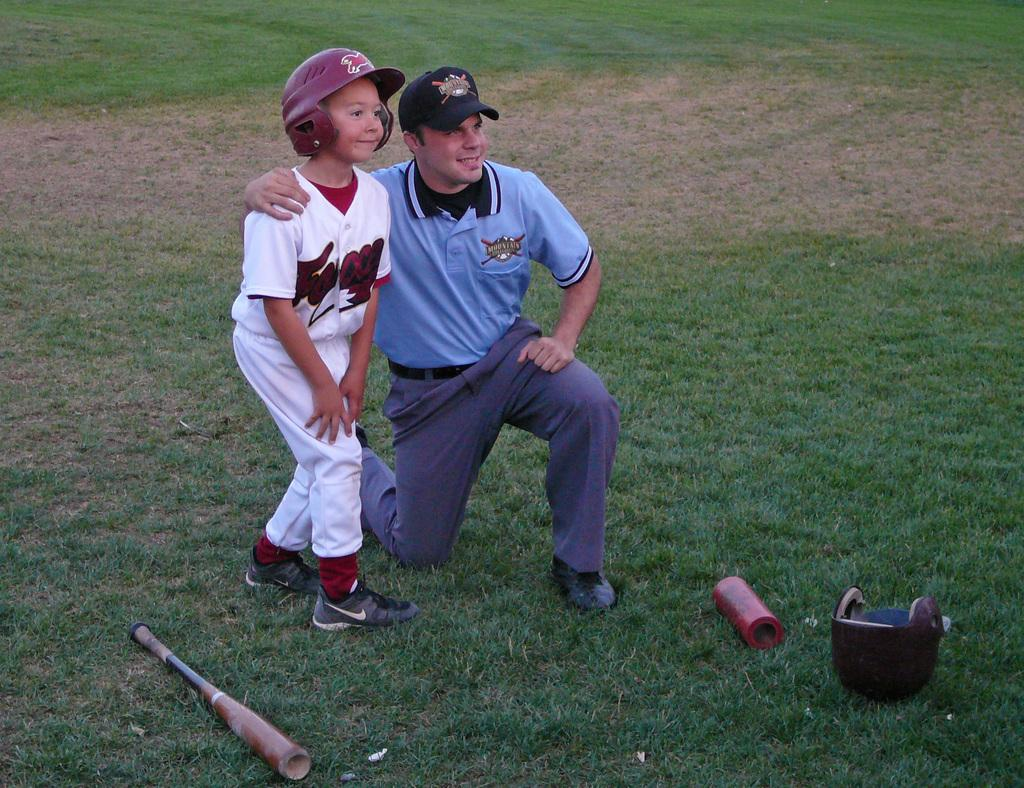How many people are in the image? There are two people in the image. What is the facial expression of the people in the image? The people are smiling. What sport-related item is present in the image? There is a bat and a helmet in the image. What is located on the grass in the image? There is an object on the grass in the image. Can you see any goldfish swimming in the image? No, there are no goldfish present in the image. What type of cherry is being used as a prop in the image? There is no cherry present in the image. 